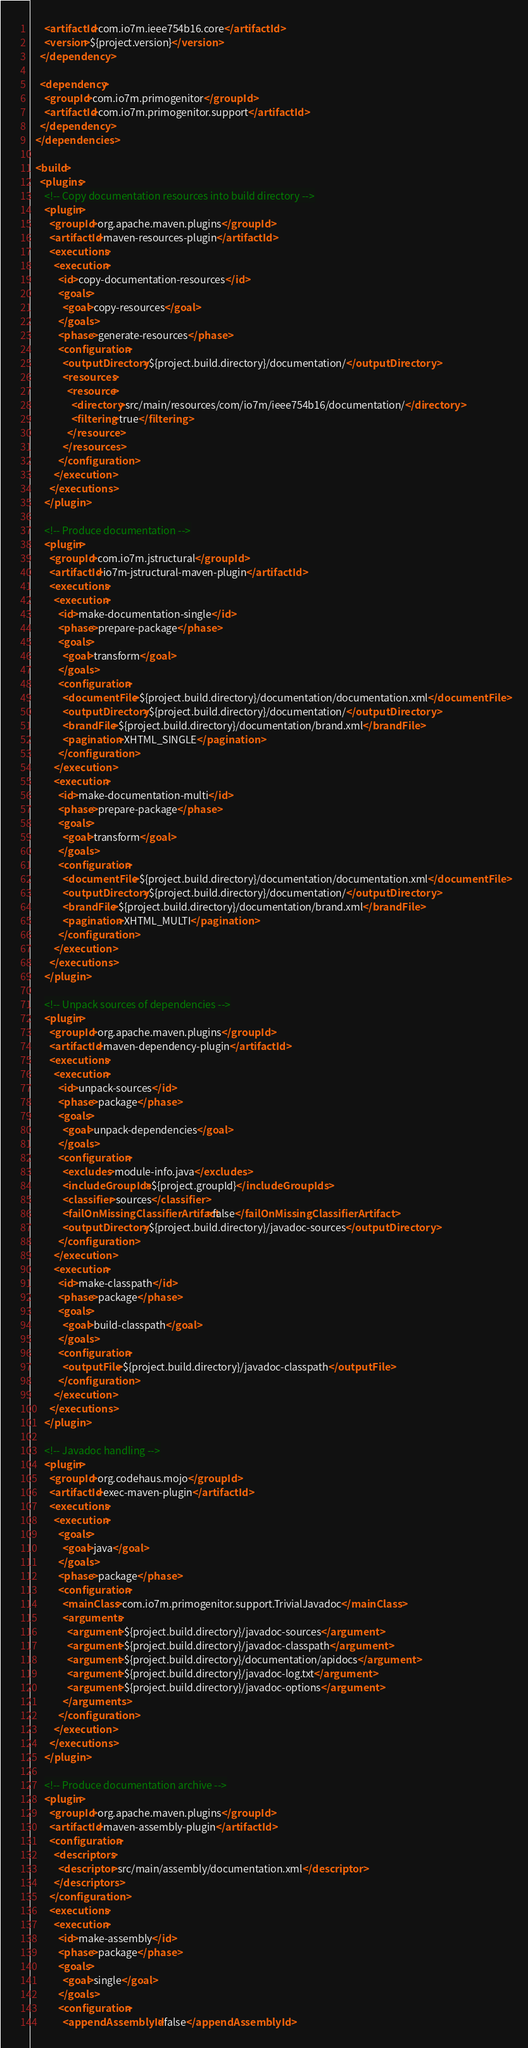<code> <loc_0><loc_0><loc_500><loc_500><_XML_>      <artifactId>com.io7m.ieee754b16.core</artifactId>
      <version>${project.version}</version>
    </dependency>

    <dependency>
      <groupId>com.io7m.primogenitor</groupId>
      <artifactId>com.io7m.primogenitor.support</artifactId>
    </dependency>
  </dependencies>

  <build>
    <plugins>
      <!-- Copy documentation resources into build directory -->
      <plugin>
        <groupId>org.apache.maven.plugins</groupId>
        <artifactId>maven-resources-plugin</artifactId>
        <executions>
          <execution>
            <id>copy-documentation-resources</id>
            <goals>
              <goal>copy-resources</goal>
            </goals>
            <phase>generate-resources</phase>
            <configuration>
              <outputDirectory>${project.build.directory}/documentation/</outputDirectory>
              <resources>
                <resource>
                  <directory>src/main/resources/com/io7m/ieee754b16/documentation/</directory>
                  <filtering>true</filtering>
                </resource>
              </resources>
            </configuration>
          </execution>
        </executions>
      </plugin>

      <!-- Produce documentation -->
      <plugin>
        <groupId>com.io7m.jstructural</groupId>
        <artifactId>io7m-jstructural-maven-plugin</artifactId>
        <executions>
          <execution>
            <id>make-documentation-single</id>
            <phase>prepare-package</phase>
            <goals>
              <goal>transform</goal>
            </goals>
            <configuration>
              <documentFile>${project.build.directory}/documentation/documentation.xml</documentFile>
              <outputDirectory>${project.build.directory}/documentation/</outputDirectory>
              <brandFile>${project.build.directory}/documentation/brand.xml</brandFile>
              <pagination>XHTML_SINGLE</pagination>
            </configuration>
          </execution>
          <execution>
            <id>make-documentation-multi</id>
            <phase>prepare-package</phase>
            <goals>
              <goal>transform</goal>
            </goals>
            <configuration>
              <documentFile>${project.build.directory}/documentation/documentation.xml</documentFile>
              <outputDirectory>${project.build.directory}/documentation/</outputDirectory>
              <brandFile>${project.build.directory}/documentation/brand.xml</brandFile>
              <pagination>XHTML_MULTI</pagination>
            </configuration>
          </execution>
        </executions>
      </plugin>

      <!-- Unpack sources of dependencies -->
      <plugin>
        <groupId>org.apache.maven.plugins</groupId>
        <artifactId>maven-dependency-plugin</artifactId>
        <executions>
          <execution>
            <id>unpack-sources</id>
            <phase>package</phase>
            <goals>
              <goal>unpack-dependencies</goal>
            </goals>
            <configuration>
              <excludes>module-info.java</excludes>
              <includeGroupIds>${project.groupId}</includeGroupIds>
              <classifier>sources</classifier>
              <failOnMissingClassifierArtifact>false</failOnMissingClassifierArtifact>
              <outputDirectory>${project.build.directory}/javadoc-sources</outputDirectory>
            </configuration>
          </execution>
          <execution>
            <id>make-classpath</id>
            <phase>package</phase>
            <goals>
              <goal>build-classpath</goal>
            </goals>
            <configuration>
              <outputFile>${project.build.directory}/javadoc-classpath</outputFile>
            </configuration>
          </execution>
        </executions>
      </plugin>

      <!-- Javadoc handling -->
      <plugin>
        <groupId>org.codehaus.mojo</groupId>
        <artifactId>exec-maven-plugin</artifactId>
        <executions>
          <execution>
            <goals>
              <goal>java</goal>
            </goals>
            <phase>package</phase>
            <configuration>
              <mainClass>com.io7m.primogenitor.support.TrivialJavadoc</mainClass>
              <arguments>
                <argument>${project.build.directory}/javadoc-sources</argument>
                <argument>${project.build.directory}/javadoc-classpath</argument>
                <argument>${project.build.directory}/documentation/apidocs</argument>
                <argument>${project.build.directory}/javadoc-log.txt</argument>
                <argument>${project.build.directory}/javadoc-options</argument>
              </arguments>
            </configuration>
          </execution>
        </executions>
      </plugin>

      <!-- Produce documentation archive -->
      <plugin>
        <groupId>org.apache.maven.plugins</groupId>
        <artifactId>maven-assembly-plugin</artifactId>
        <configuration>
          <descriptors>
            <descriptor>src/main/assembly/documentation.xml</descriptor>
          </descriptors>
        </configuration>
        <executions>
          <execution>
            <id>make-assembly</id>
            <phase>package</phase>
            <goals>
              <goal>single</goal>
            </goals>
            <configuration>
              <appendAssemblyId>false</appendAssemblyId></code> 